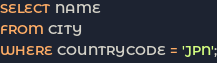<code> <loc_0><loc_0><loc_500><loc_500><_SQL_>SELECT NAME
FROM CITY
WHERE COUNTRYCODE = 'JPN';
</code> 